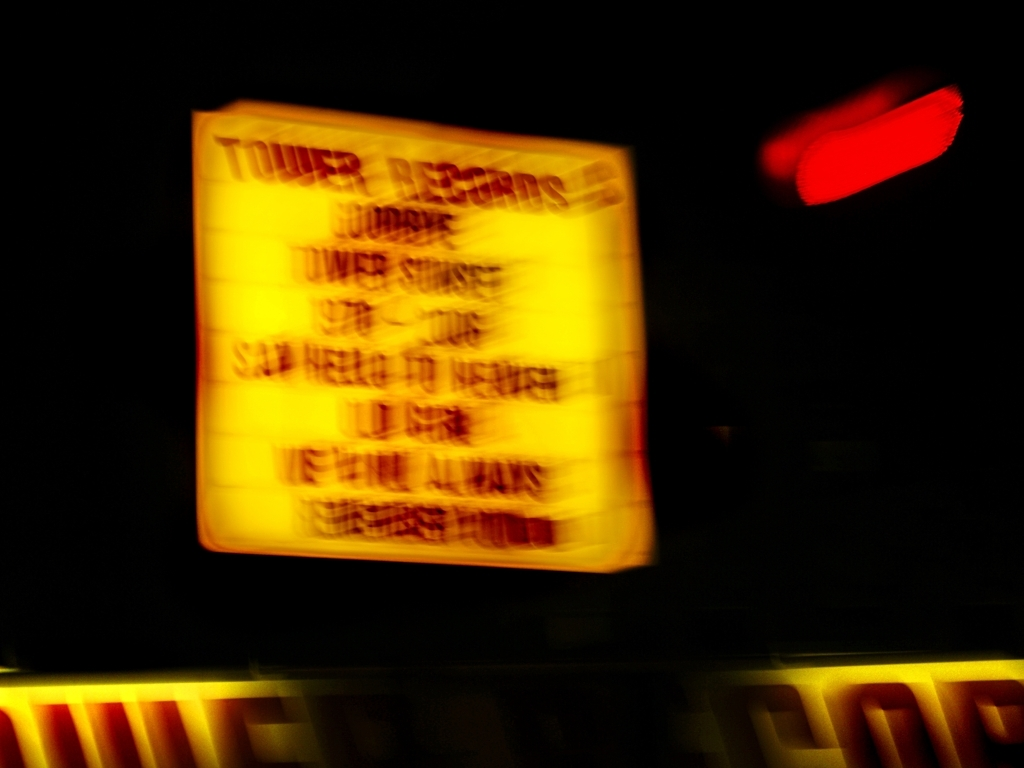What could have caused the quality issues seen here? The quality issues such as the motion blur could originate from several factors, such as camera shake, a slow shutter speed in low light conditions, or a moving subject/object when the photograph was taken. Is there anything that can be done to improve the quality of a photo like this? Improving a photo like this could involve using image stabilization features, increasing the shutter speed, ensuring the camera is steady when capturing, or using post-processing techniques to sharpen the image, although effectiveness may be limited due to the extent of the blur. 